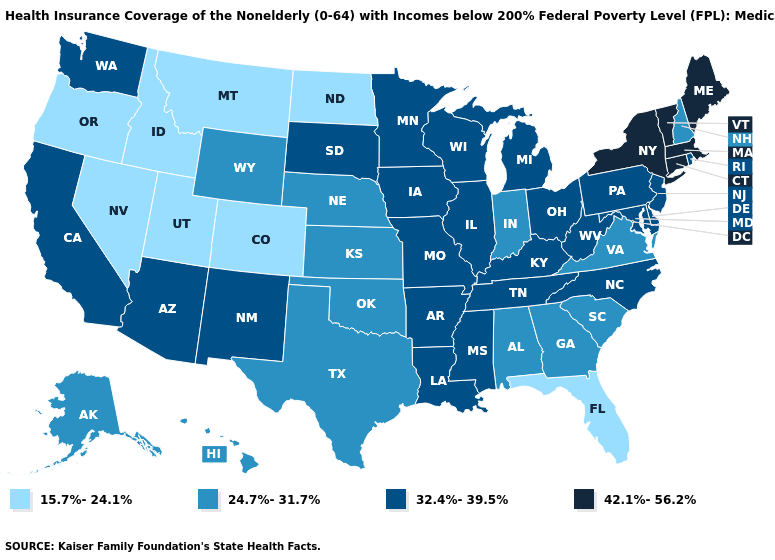Does Arkansas have a higher value than Georgia?
Be succinct. Yes. Name the states that have a value in the range 15.7%-24.1%?
Answer briefly. Colorado, Florida, Idaho, Montana, Nevada, North Dakota, Oregon, Utah. Does Idaho have the lowest value in the USA?
Keep it brief. Yes. Does Florida have the lowest value in the USA?
Answer briefly. Yes. Among the states that border Illinois , does Missouri have the highest value?
Quick response, please. Yes. What is the value of Missouri?
Keep it brief. 32.4%-39.5%. Name the states that have a value in the range 24.7%-31.7%?
Answer briefly. Alabama, Alaska, Georgia, Hawaii, Indiana, Kansas, Nebraska, New Hampshire, Oklahoma, South Carolina, Texas, Virginia, Wyoming. Does South Carolina have the same value as New Mexico?
Write a very short answer. No. What is the lowest value in the MidWest?
Write a very short answer. 15.7%-24.1%. Among the states that border Colorado , does Arizona have the highest value?
Give a very brief answer. Yes. Name the states that have a value in the range 42.1%-56.2%?
Short answer required. Connecticut, Maine, Massachusetts, New York, Vermont. Name the states that have a value in the range 42.1%-56.2%?
Give a very brief answer. Connecticut, Maine, Massachusetts, New York, Vermont. What is the value of Vermont?
Concise answer only. 42.1%-56.2%. Name the states that have a value in the range 24.7%-31.7%?
Keep it brief. Alabama, Alaska, Georgia, Hawaii, Indiana, Kansas, Nebraska, New Hampshire, Oklahoma, South Carolina, Texas, Virginia, Wyoming. Name the states that have a value in the range 15.7%-24.1%?
Answer briefly. Colorado, Florida, Idaho, Montana, Nevada, North Dakota, Oregon, Utah. 